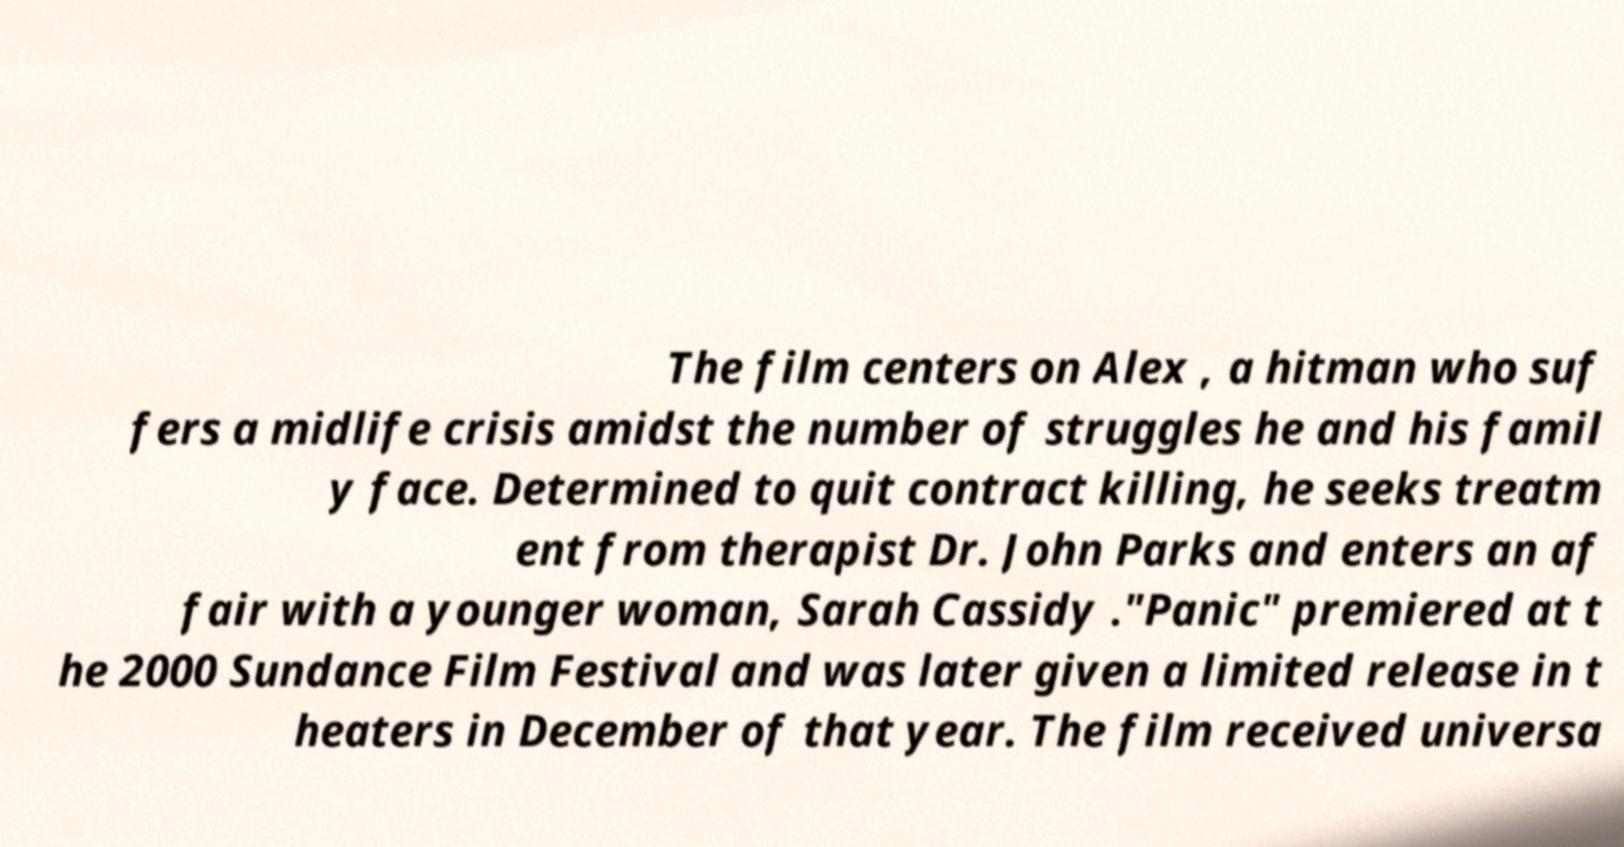What messages or text are displayed in this image? I need them in a readable, typed format. The film centers on Alex , a hitman who suf fers a midlife crisis amidst the number of struggles he and his famil y face. Determined to quit contract killing, he seeks treatm ent from therapist Dr. John Parks and enters an af fair with a younger woman, Sarah Cassidy ."Panic" premiered at t he 2000 Sundance Film Festival and was later given a limited release in t heaters in December of that year. The film received universa 